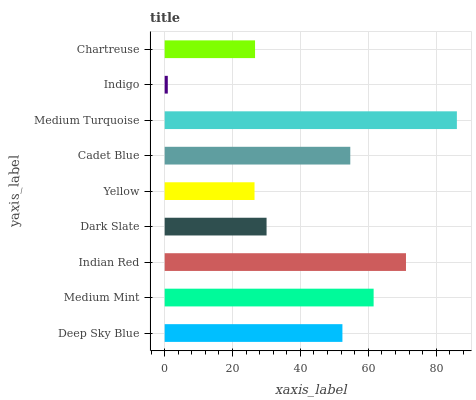Is Indigo the minimum?
Answer yes or no. Yes. Is Medium Turquoise the maximum?
Answer yes or no. Yes. Is Medium Mint the minimum?
Answer yes or no. No. Is Medium Mint the maximum?
Answer yes or no. No. Is Medium Mint greater than Deep Sky Blue?
Answer yes or no. Yes. Is Deep Sky Blue less than Medium Mint?
Answer yes or no. Yes. Is Deep Sky Blue greater than Medium Mint?
Answer yes or no. No. Is Medium Mint less than Deep Sky Blue?
Answer yes or no. No. Is Deep Sky Blue the high median?
Answer yes or no. Yes. Is Deep Sky Blue the low median?
Answer yes or no. Yes. Is Indigo the high median?
Answer yes or no. No. Is Medium Turquoise the low median?
Answer yes or no. No. 